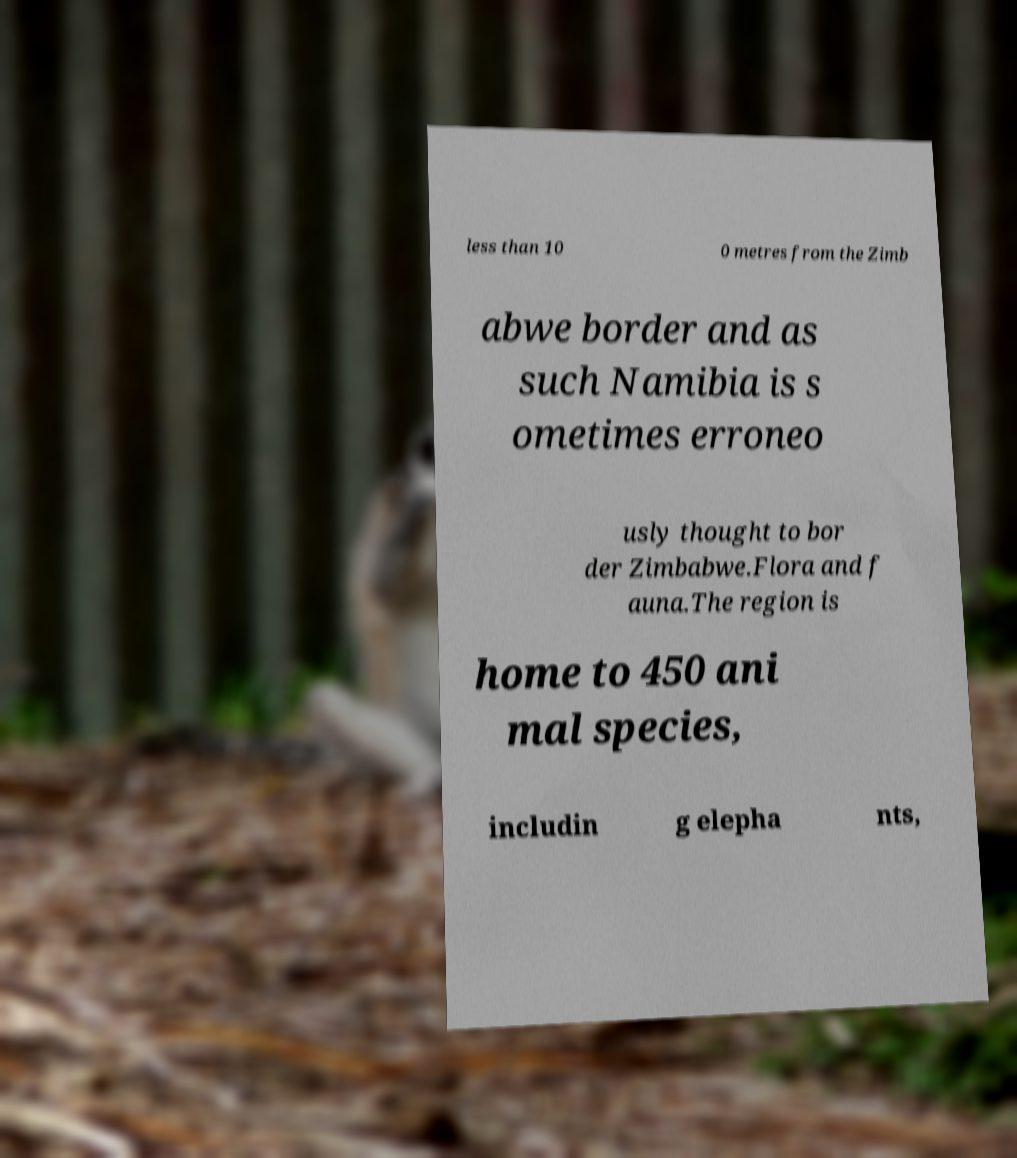Can you read and provide the text displayed in the image?This photo seems to have some interesting text. Can you extract and type it out for me? less than 10 0 metres from the Zimb abwe border and as such Namibia is s ometimes erroneo usly thought to bor der Zimbabwe.Flora and f auna.The region is home to 450 ani mal species, includin g elepha nts, 